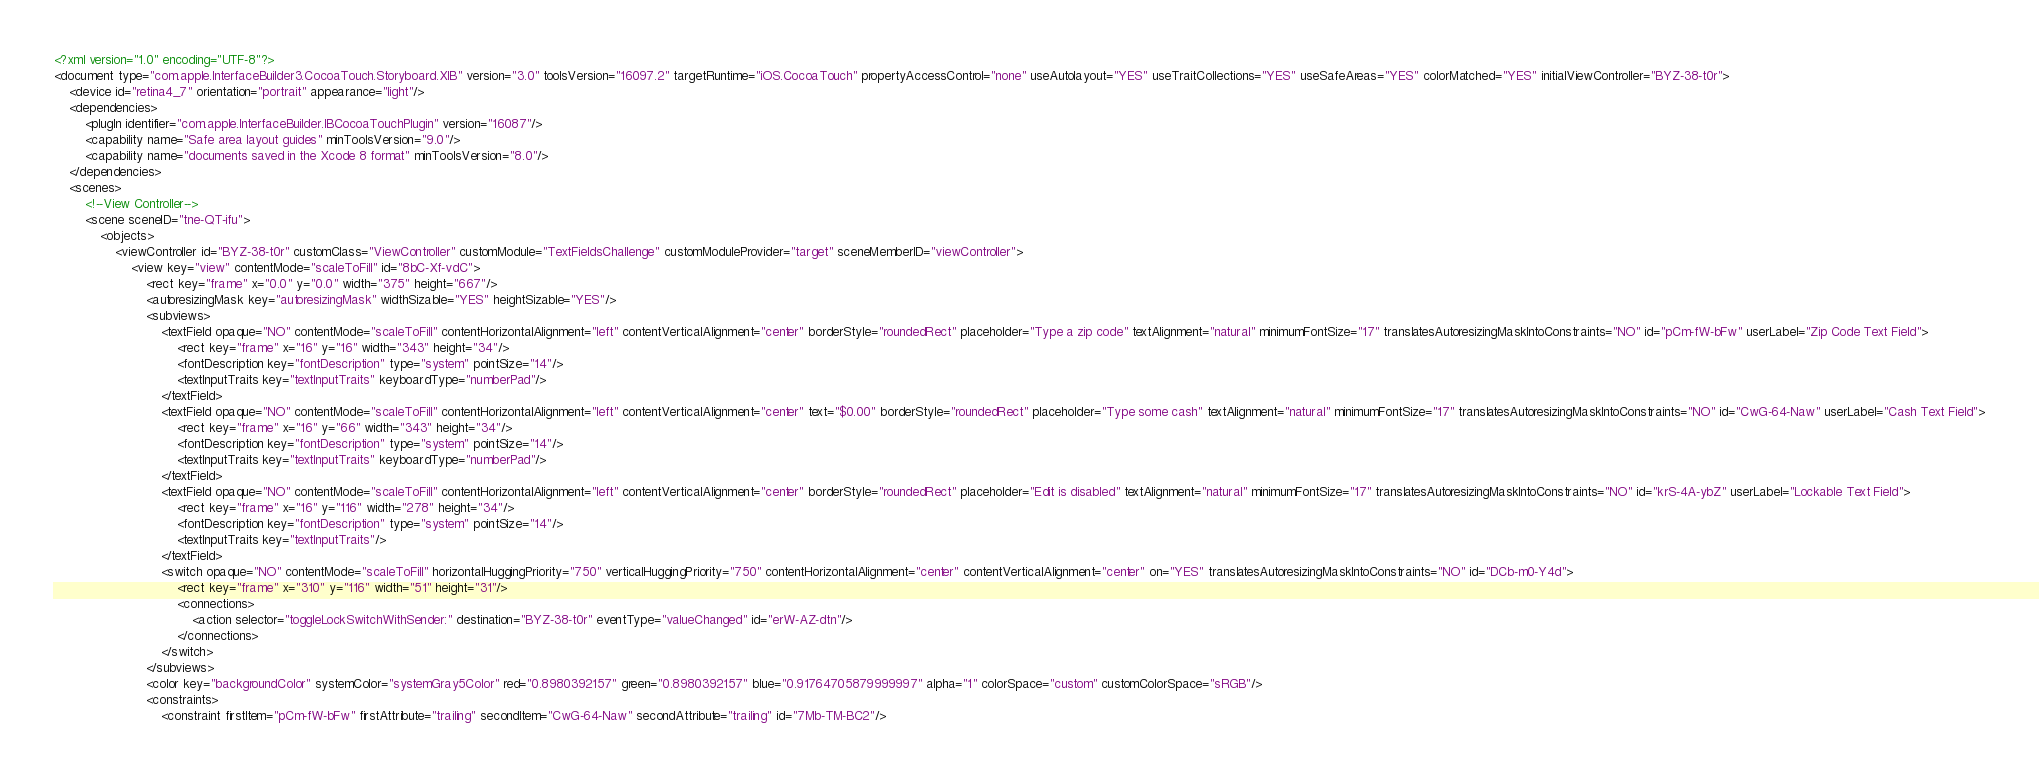<code> <loc_0><loc_0><loc_500><loc_500><_XML_><?xml version="1.0" encoding="UTF-8"?>
<document type="com.apple.InterfaceBuilder3.CocoaTouch.Storyboard.XIB" version="3.0" toolsVersion="16097.2" targetRuntime="iOS.CocoaTouch" propertyAccessControl="none" useAutolayout="YES" useTraitCollections="YES" useSafeAreas="YES" colorMatched="YES" initialViewController="BYZ-38-t0r">
    <device id="retina4_7" orientation="portrait" appearance="light"/>
    <dependencies>
        <plugIn identifier="com.apple.InterfaceBuilder.IBCocoaTouchPlugin" version="16087"/>
        <capability name="Safe area layout guides" minToolsVersion="9.0"/>
        <capability name="documents saved in the Xcode 8 format" minToolsVersion="8.0"/>
    </dependencies>
    <scenes>
        <!--View Controller-->
        <scene sceneID="tne-QT-ifu">
            <objects>
                <viewController id="BYZ-38-t0r" customClass="ViewController" customModule="TextFieldsChallenge" customModuleProvider="target" sceneMemberID="viewController">
                    <view key="view" contentMode="scaleToFill" id="8bC-Xf-vdC">
                        <rect key="frame" x="0.0" y="0.0" width="375" height="667"/>
                        <autoresizingMask key="autoresizingMask" widthSizable="YES" heightSizable="YES"/>
                        <subviews>
                            <textField opaque="NO" contentMode="scaleToFill" contentHorizontalAlignment="left" contentVerticalAlignment="center" borderStyle="roundedRect" placeholder="Type a zip code" textAlignment="natural" minimumFontSize="17" translatesAutoresizingMaskIntoConstraints="NO" id="pCm-fW-bFw" userLabel="Zip Code Text Field">
                                <rect key="frame" x="16" y="16" width="343" height="34"/>
                                <fontDescription key="fontDescription" type="system" pointSize="14"/>
                                <textInputTraits key="textInputTraits" keyboardType="numberPad"/>
                            </textField>
                            <textField opaque="NO" contentMode="scaleToFill" contentHorizontalAlignment="left" contentVerticalAlignment="center" text="$0.00" borderStyle="roundedRect" placeholder="Type some cash" textAlignment="natural" minimumFontSize="17" translatesAutoresizingMaskIntoConstraints="NO" id="CwG-64-Naw" userLabel="Cash Text Field">
                                <rect key="frame" x="16" y="66" width="343" height="34"/>
                                <fontDescription key="fontDescription" type="system" pointSize="14"/>
                                <textInputTraits key="textInputTraits" keyboardType="numberPad"/>
                            </textField>
                            <textField opaque="NO" contentMode="scaleToFill" contentHorizontalAlignment="left" contentVerticalAlignment="center" borderStyle="roundedRect" placeholder="Edit is disabled" textAlignment="natural" minimumFontSize="17" translatesAutoresizingMaskIntoConstraints="NO" id="krS-4A-ybZ" userLabel="Lockable Text Field">
                                <rect key="frame" x="16" y="116" width="278" height="34"/>
                                <fontDescription key="fontDescription" type="system" pointSize="14"/>
                                <textInputTraits key="textInputTraits"/>
                            </textField>
                            <switch opaque="NO" contentMode="scaleToFill" horizontalHuggingPriority="750" verticalHuggingPriority="750" contentHorizontalAlignment="center" contentVerticalAlignment="center" on="YES" translatesAutoresizingMaskIntoConstraints="NO" id="DCb-m0-Y4d">
                                <rect key="frame" x="310" y="116" width="51" height="31"/>
                                <connections>
                                    <action selector="toggleLockSwitchWithSender:" destination="BYZ-38-t0r" eventType="valueChanged" id="erW-AZ-dtn"/>
                                </connections>
                            </switch>
                        </subviews>
                        <color key="backgroundColor" systemColor="systemGray5Color" red="0.8980392157" green="0.8980392157" blue="0.91764705879999997" alpha="1" colorSpace="custom" customColorSpace="sRGB"/>
                        <constraints>
                            <constraint firstItem="pCm-fW-bFw" firstAttribute="trailing" secondItem="CwG-64-Naw" secondAttribute="trailing" id="7Mb-TM-BC2"/></code> 